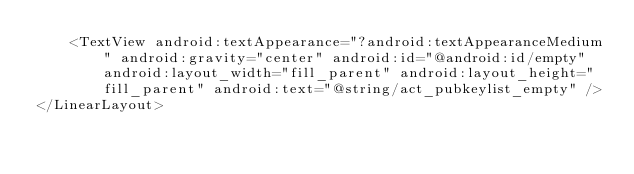<code> <loc_0><loc_0><loc_500><loc_500><_XML_>    <TextView android:textAppearance="?android:textAppearanceMedium" android:gravity="center" android:id="@android:id/empty" android:layout_width="fill_parent" android:layout_height="fill_parent" android:text="@string/act_pubkeylist_empty" />
</LinearLayout>
</code> 